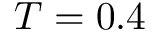Convert formula to latex. <formula><loc_0><loc_0><loc_500><loc_500>T = 0 . 4</formula> 